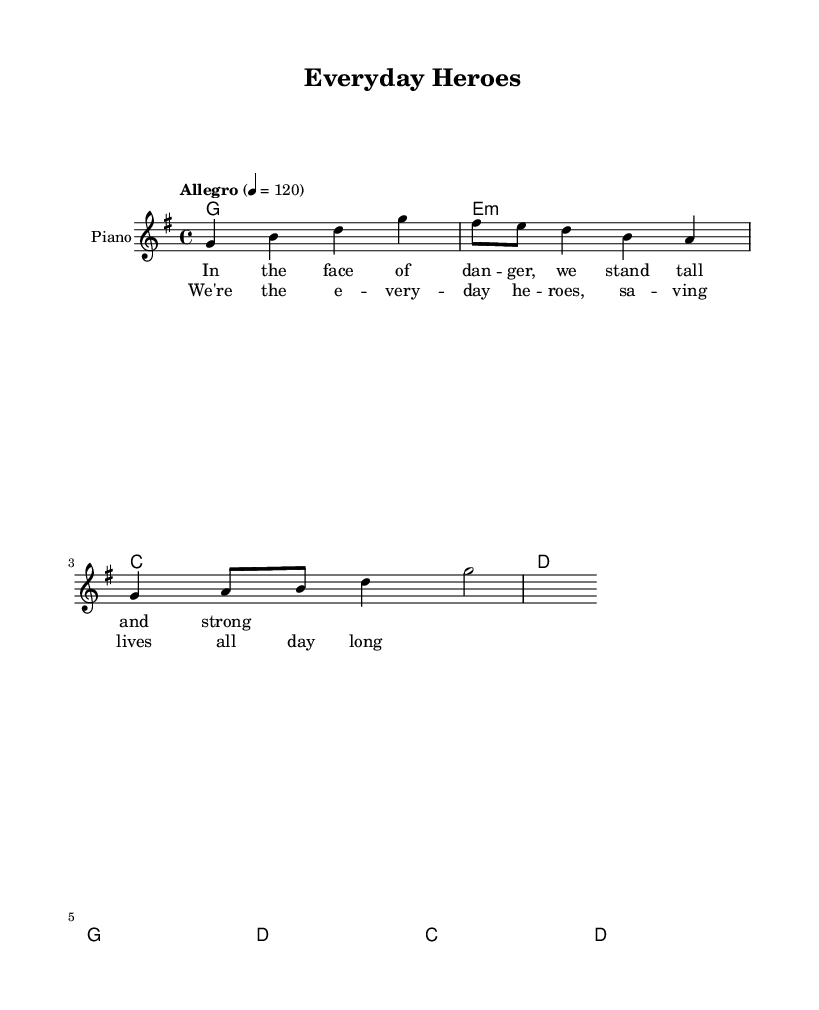What is the key signature of this music? The key signature is G major, which has one sharp (F#). This can be found at the beginning of the sheet music in the key signature section.
Answer: G major What is the time signature of this piece? The time signature is 4/4, which means there are four beats in each measure and each beat is a quarter note. This is indicated at the beginning of the score.
Answer: 4/4 What is the tempo marking for this piece? The tempo marking is Allegro and it is set to 120 beats per minute. This is also specified at the beginning of the score, in the tempo section.
Answer: Allegro 120 How many measures are in the melody? The melody consists of 8 measures, which can be counted from the beginning to the end of the melody section in the sheet music.
Answer: 8 measures What are the first four notes of the melody? The first four notes of the melody are G, B, D, and G. These notes are found at the beginning of the melody line and are clearly notated.
Answer: G, B, D, G What is the theme of the chorus lyrics? The theme of the chorus lyrics is about everyday heroes who save lives consistently. This can be inferred from the phrasing “We're the everyday heroes, saving lives all day long.”
Answer: Everyday heroes saving lives Which chord follows the G chord in the harmony section? The chord that follows the G chord is E minor. This can be determined by looking at the chord progression in the harmony section, where the G chord is followed by E minor.
Answer: E minor 